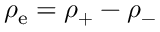<formula> <loc_0><loc_0><loc_500><loc_500>\rho _ { e } = \rho _ { + } - \rho _ { - }</formula> 